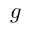Convert formula to latex. <formula><loc_0><loc_0><loc_500><loc_500>g</formula> 